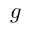Convert formula to latex. <formula><loc_0><loc_0><loc_500><loc_500>g</formula> 